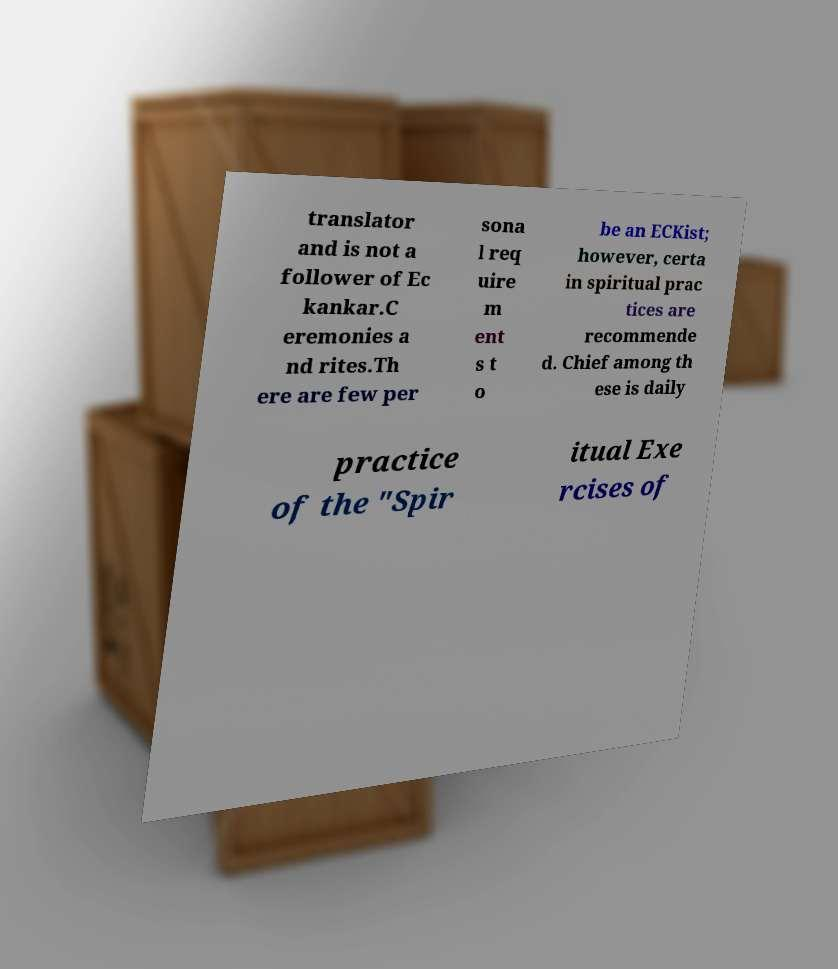I need the written content from this picture converted into text. Can you do that? translator and is not a follower of Ec kankar.C eremonies a nd rites.Th ere are few per sona l req uire m ent s t o be an ECKist; however, certa in spiritual prac tices are recommende d. Chief among th ese is daily practice of the "Spir itual Exe rcises of 